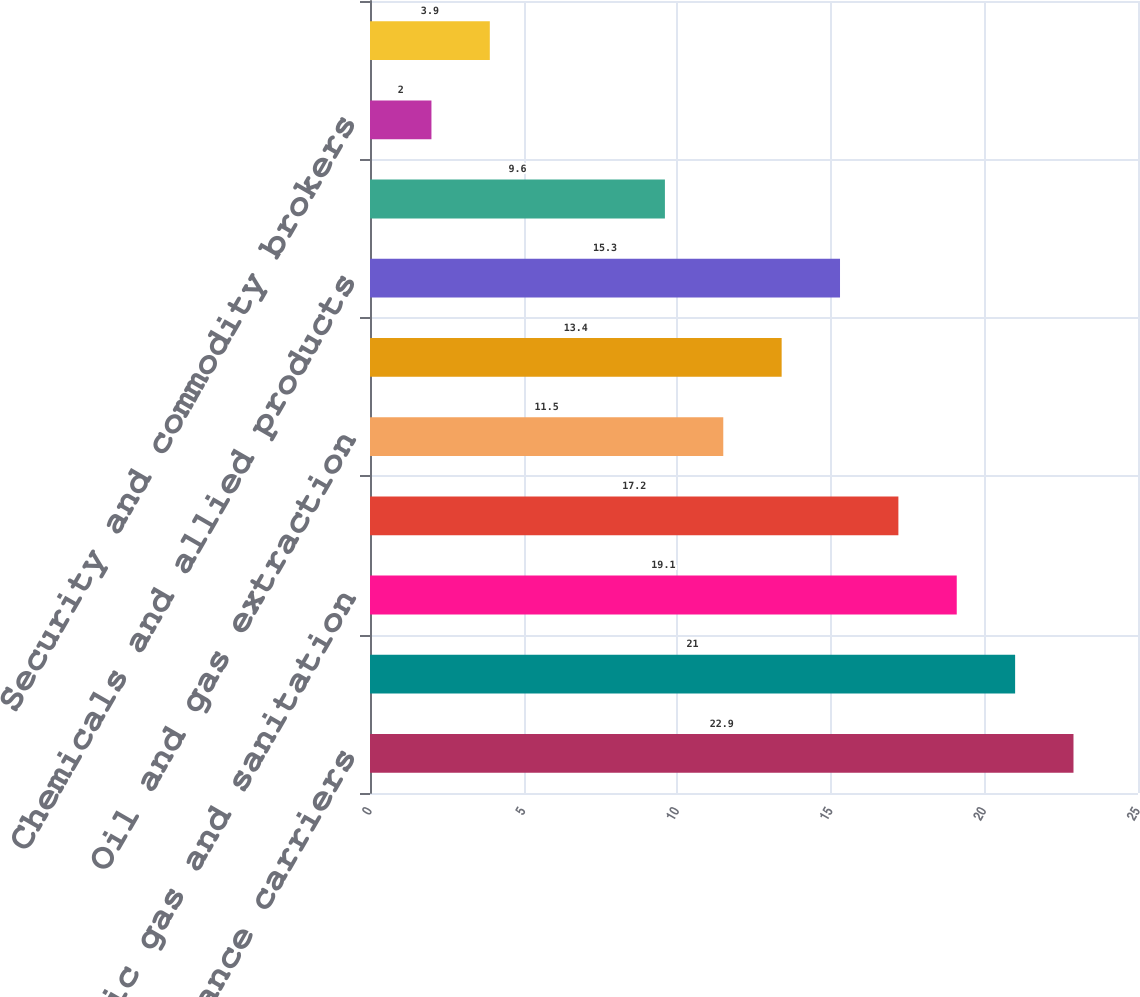Convert chart to OTSL. <chart><loc_0><loc_0><loc_500><loc_500><bar_chart><fcel>Insurance carriers<fcel>Depository institutions<fcel>Electric gas and sanitation<fcel>Nondepository credit<fcel>Oil and gas extraction<fcel>Communications<fcel>Chemicals and allied products<fcel>Food and kindred products<fcel>Security and commodity brokers<fcel>Transportation equipment<nl><fcel>22.9<fcel>21<fcel>19.1<fcel>17.2<fcel>11.5<fcel>13.4<fcel>15.3<fcel>9.6<fcel>2<fcel>3.9<nl></chart> 